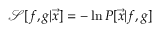Convert formula to latex. <formula><loc_0><loc_0><loc_500><loc_500>\mathcal { S } [ f , g | \vec { x } ] = - \ln P [ \vec { x } | f , g ]</formula> 